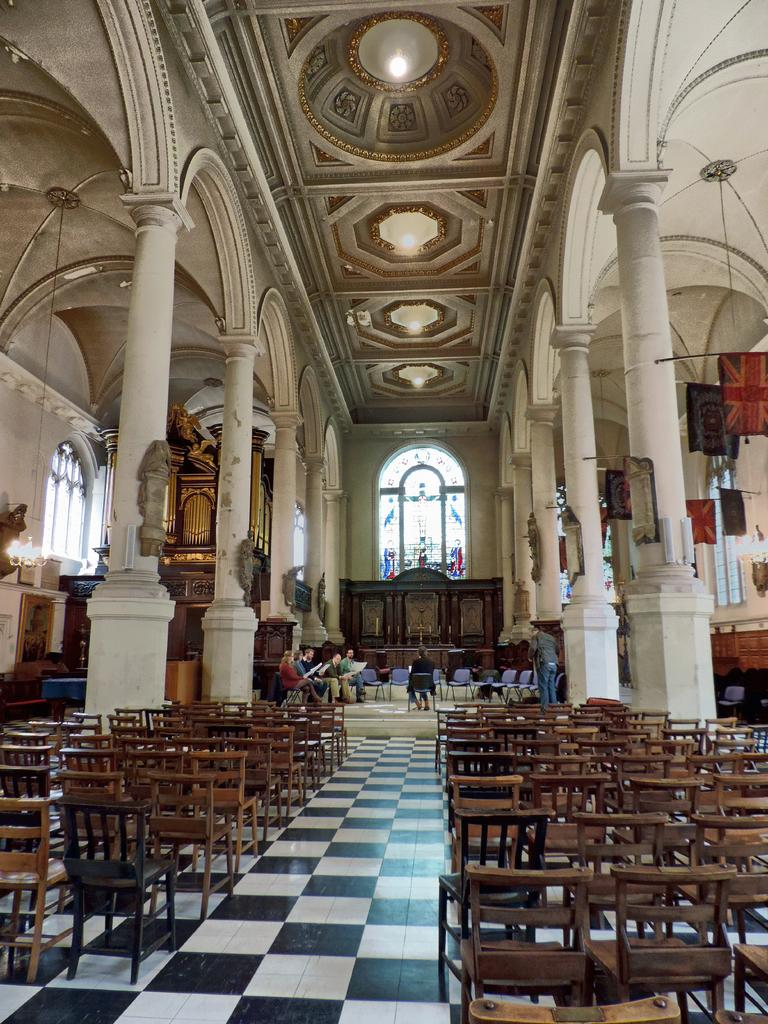What architectural features can be seen in the image? There are pillars and a wall in the image. What type of furniture is present in the image? There are chairs in the image. Are there any people in the image? Yes, there are persons in the image. What decorative elements can be seen in the image? There are flags and lights in the image. What structural elements are visible in the image? There is a ceiling in the image. Are there any openings to the outside in the image? Yes, there are windows in the image. Who is the owner of the cactus in the image? There is no cactus present in the image. What is the name of the person the main character has a crush on in the image? There is no information about a crush or a main character in the image. 